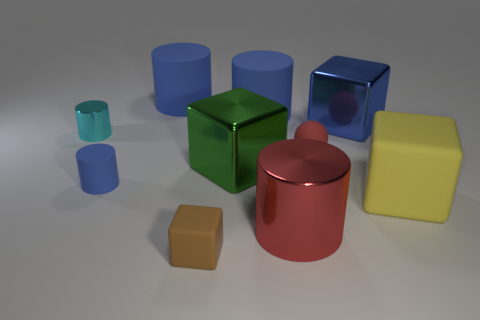How many blue cylinders must be subtracted to get 1 blue cylinders? 2 Subtract all green blocks. How many blue cylinders are left? 3 Subtract all cyan shiny cylinders. How many cylinders are left? 4 Subtract 1 cylinders. How many cylinders are left? 4 Subtract all cyan cylinders. How many cylinders are left? 4 Subtract all gray cubes. Subtract all red balls. How many cubes are left? 4 Subtract all spheres. How many objects are left? 9 Add 9 big green objects. How many big green objects exist? 10 Subtract 0 gray blocks. How many objects are left? 10 Subtract all cyan cylinders. Subtract all large matte objects. How many objects are left? 6 